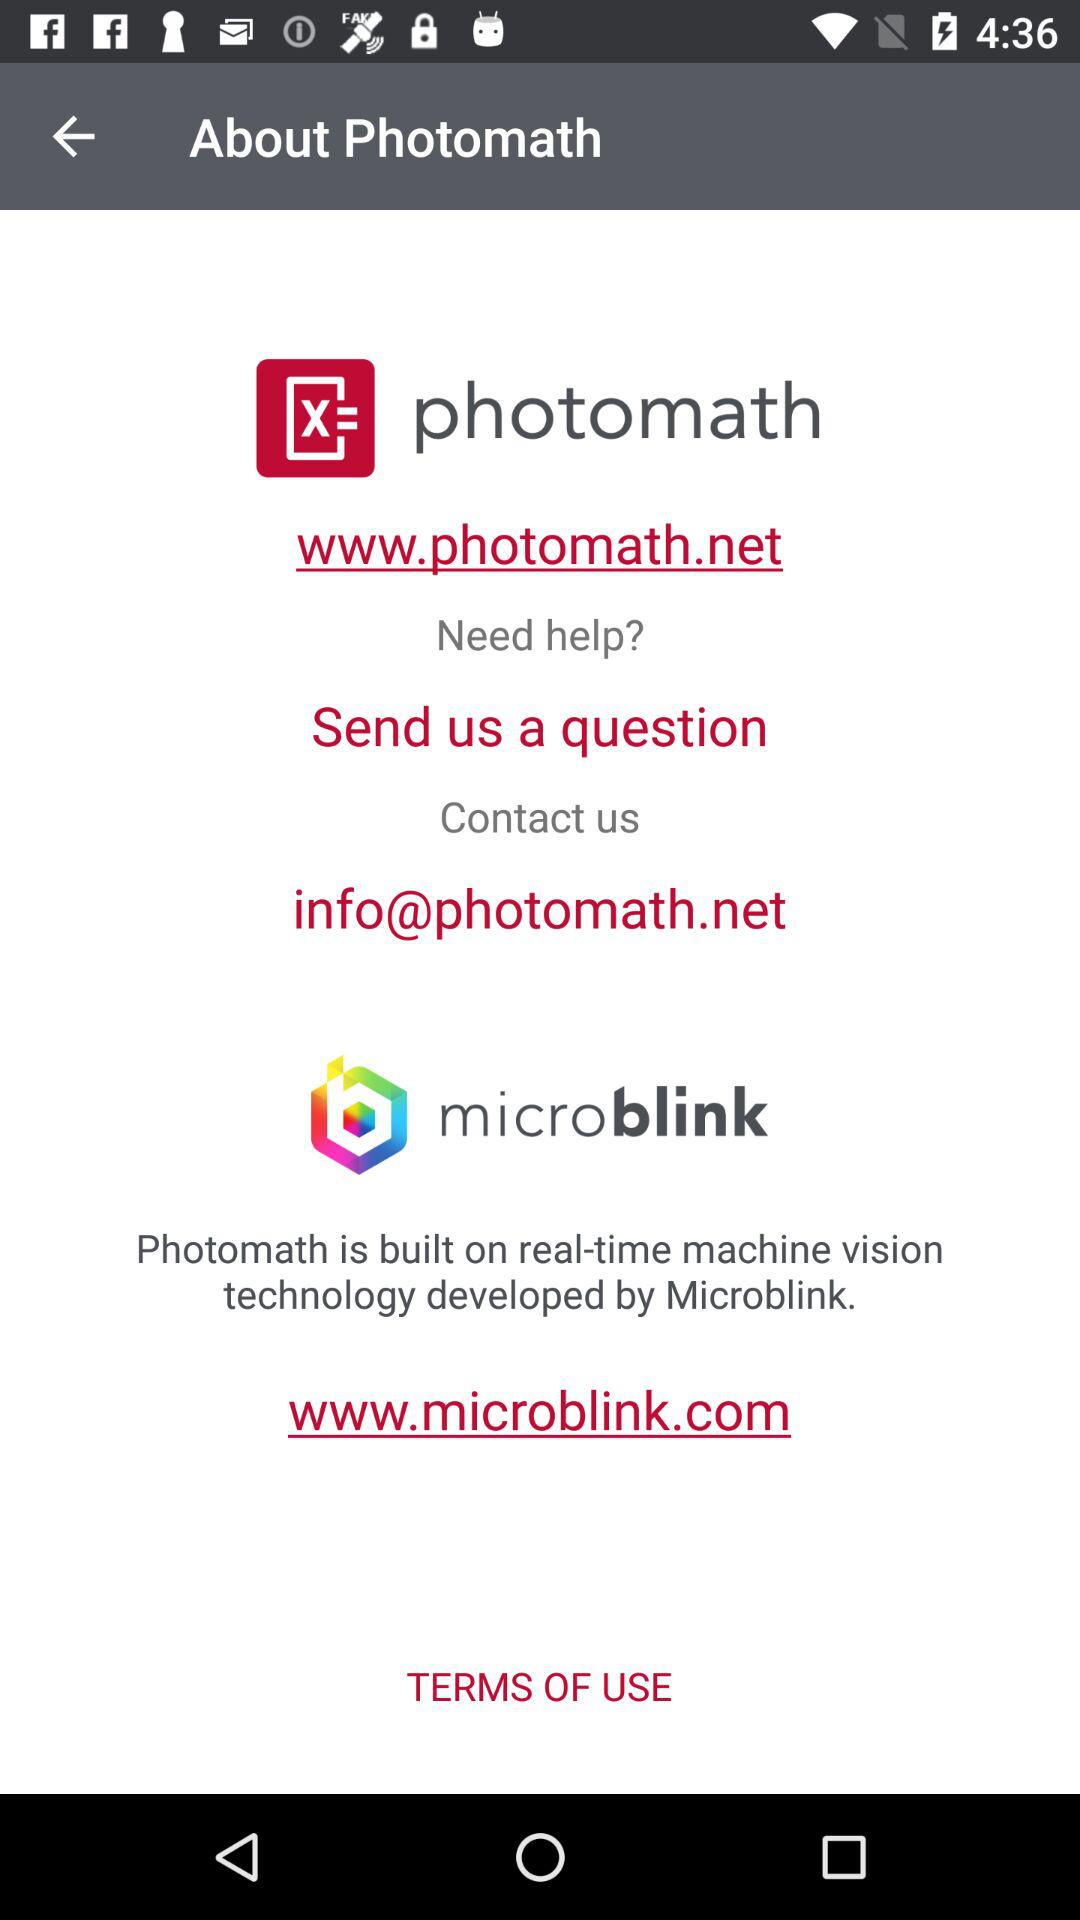What is the email address to contact us? The email address is info@photomath.net. 